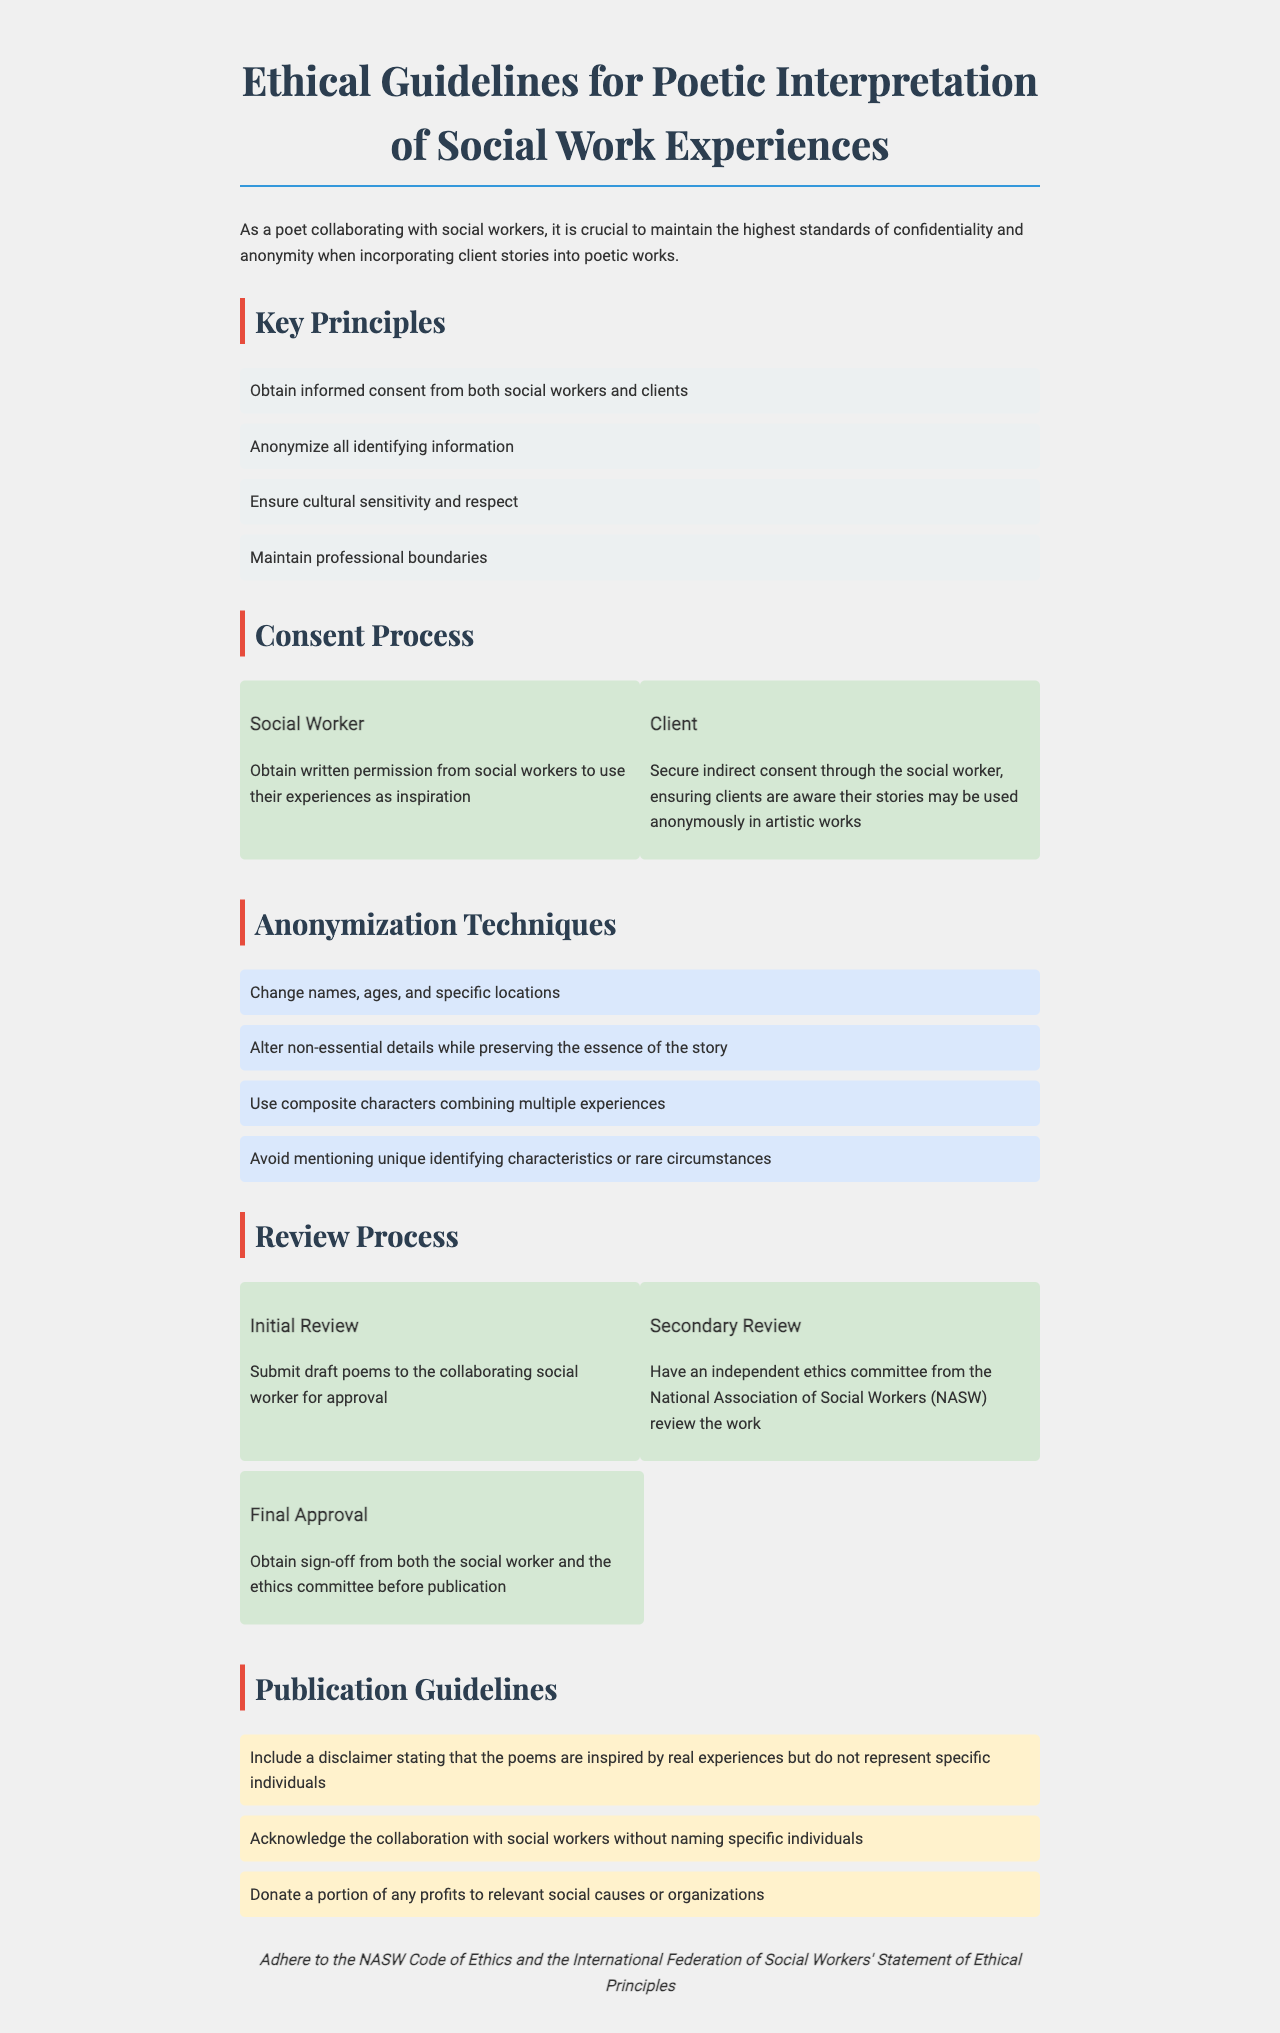What is the title of the document? The title appears at the top of the document and states the main subject it addresses.
Answer: Ethical Guidelines for Poetic Interpretation of Social Work Experiences What is the first key principle mentioned? The first key principle is listed under the "Key Principles" section and outlines an important ethical requirement.
Answer: Obtain informed consent from both social workers and clients How many anonymization techniques are provided? The number of techniques can be counted in the "Anonymization Techniques" section of the document.
Answer: Four Who conducts the secondary review? The document specifies who will review the work during the secondary review process.
Answer: Independent ethics committee from the National Association of Social Workers (NASW) What disclaimer should be included for publication? The guideline for the disclaimer is mentioned in the "Publication Guidelines" section of the document.
Answer: Include a disclaimer stating that the poems are inspired by real experiences but do not represent specific individuals How many processes are involved in the consent process? The document outlines the steps taken for obtaining consent, which can be identified in the "Consent Process" section.
Answer: Two What is required for final approval? This is addressed in the "Review Process" section, which outlines what must happen before publication.
Answer: Obtain sign-off from both the social worker and the ethics committee before publication What ethical code should be adhered to? The document mentions specific ethical guidelines that must be followed, found at the end.
Answer: NASW Code of Ethics and the International Federation of Social Workers' Statement of Ethical Principles 